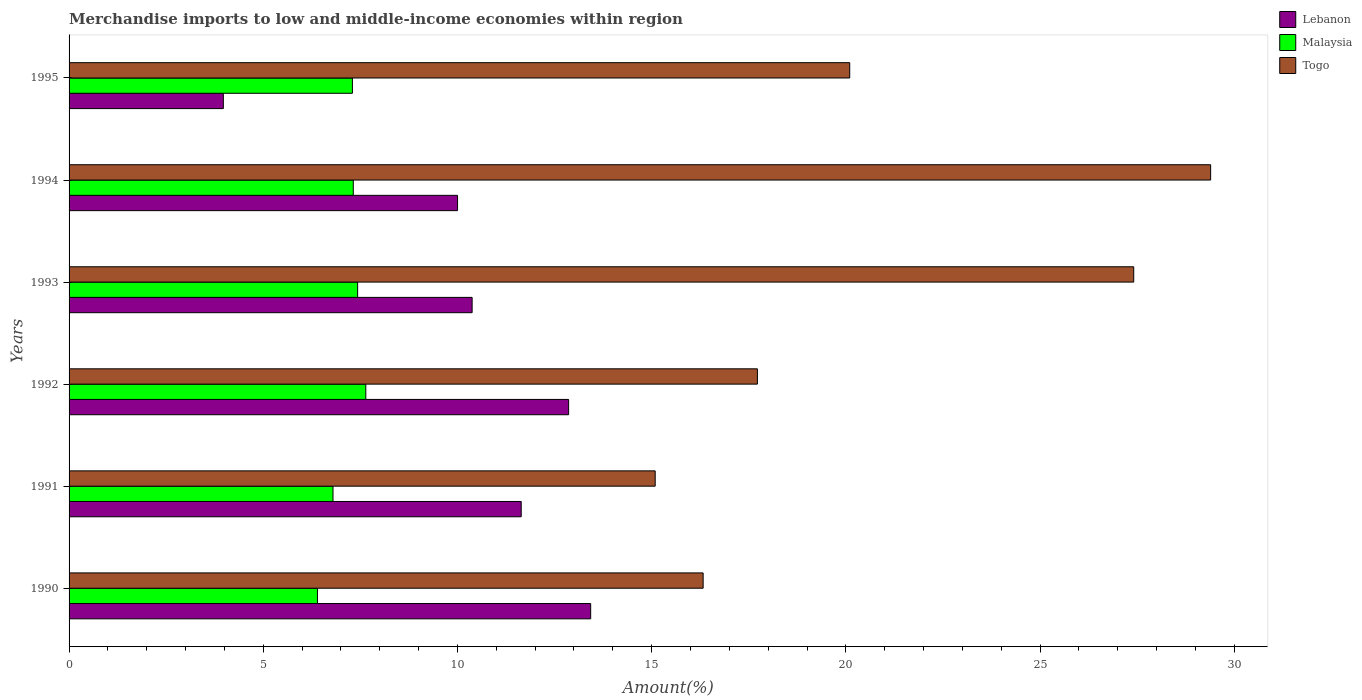How many groups of bars are there?
Provide a succinct answer. 6. How many bars are there on the 1st tick from the bottom?
Your answer should be very brief. 3. What is the percentage of amount earned from merchandise imports in Togo in 1991?
Keep it short and to the point. 15.09. Across all years, what is the maximum percentage of amount earned from merchandise imports in Togo?
Keep it short and to the point. 29.39. Across all years, what is the minimum percentage of amount earned from merchandise imports in Togo?
Your answer should be very brief. 15.09. In which year was the percentage of amount earned from merchandise imports in Lebanon maximum?
Offer a terse response. 1990. What is the total percentage of amount earned from merchandise imports in Malaysia in the graph?
Offer a very short reply. 42.87. What is the difference between the percentage of amount earned from merchandise imports in Togo in 1990 and that in 1994?
Your answer should be compact. -13.07. What is the difference between the percentage of amount earned from merchandise imports in Lebanon in 1990 and the percentage of amount earned from merchandise imports in Togo in 1995?
Provide a succinct answer. -6.67. What is the average percentage of amount earned from merchandise imports in Malaysia per year?
Ensure brevity in your answer.  7.15. In the year 1993, what is the difference between the percentage of amount earned from merchandise imports in Togo and percentage of amount earned from merchandise imports in Lebanon?
Your response must be concise. 17.03. In how many years, is the percentage of amount earned from merchandise imports in Togo greater than 1 %?
Your answer should be compact. 6. What is the ratio of the percentage of amount earned from merchandise imports in Malaysia in 1991 to that in 1993?
Make the answer very short. 0.91. Is the percentage of amount earned from merchandise imports in Togo in 1993 less than that in 1994?
Offer a very short reply. Yes. What is the difference between the highest and the second highest percentage of amount earned from merchandise imports in Togo?
Your answer should be very brief. 1.98. What is the difference between the highest and the lowest percentage of amount earned from merchandise imports in Lebanon?
Ensure brevity in your answer.  9.46. Is the sum of the percentage of amount earned from merchandise imports in Lebanon in 1991 and 1993 greater than the maximum percentage of amount earned from merchandise imports in Malaysia across all years?
Keep it short and to the point. Yes. What does the 2nd bar from the top in 1990 represents?
Keep it short and to the point. Malaysia. What does the 2nd bar from the bottom in 1993 represents?
Your response must be concise. Malaysia. What is the difference between two consecutive major ticks on the X-axis?
Keep it short and to the point. 5. Does the graph contain grids?
Your answer should be very brief. No. How are the legend labels stacked?
Offer a very short reply. Vertical. What is the title of the graph?
Keep it short and to the point. Merchandise imports to low and middle-income economies within region. What is the label or title of the X-axis?
Keep it short and to the point. Amount(%). What is the label or title of the Y-axis?
Provide a succinct answer. Years. What is the Amount(%) of Lebanon in 1990?
Your answer should be very brief. 13.43. What is the Amount(%) in Malaysia in 1990?
Keep it short and to the point. 6.4. What is the Amount(%) in Togo in 1990?
Offer a terse response. 16.33. What is the Amount(%) of Lebanon in 1991?
Make the answer very short. 11.64. What is the Amount(%) of Malaysia in 1991?
Provide a succinct answer. 6.8. What is the Amount(%) of Togo in 1991?
Provide a short and direct response. 15.09. What is the Amount(%) in Lebanon in 1992?
Your answer should be very brief. 12.86. What is the Amount(%) in Malaysia in 1992?
Ensure brevity in your answer.  7.64. What is the Amount(%) of Togo in 1992?
Offer a terse response. 17.72. What is the Amount(%) in Lebanon in 1993?
Your response must be concise. 10.38. What is the Amount(%) of Malaysia in 1993?
Your answer should be compact. 7.43. What is the Amount(%) in Togo in 1993?
Your answer should be compact. 27.41. What is the Amount(%) of Lebanon in 1994?
Offer a terse response. 10. What is the Amount(%) in Malaysia in 1994?
Ensure brevity in your answer.  7.32. What is the Amount(%) of Togo in 1994?
Keep it short and to the point. 29.39. What is the Amount(%) of Lebanon in 1995?
Ensure brevity in your answer.  3.97. What is the Amount(%) in Malaysia in 1995?
Provide a succinct answer. 7.3. What is the Amount(%) in Togo in 1995?
Keep it short and to the point. 20.1. Across all years, what is the maximum Amount(%) in Lebanon?
Keep it short and to the point. 13.43. Across all years, what is the maximum Amount(%) in Malaysia?
Make the answer very short. 7.64. Across all years, what is the maximum Amount(%) of Togo?
Keep it short and to the point. 29.39. Across all years, what is the minimum Amount(%) of Lebanon?
Provide a succinct answer. 3.97. Across all years, what is the minimum Amount(%) of Malaysia?
Give a very brief answer. 6.4. Across all years, what is the minimum Amount(%) in Togo?
Offer a terse response. 15.09. What is the total Amount(%) of Lebanon in the graph?
Make the answer very short. 62.29. What is the total Amount(%) in Malaysia in the graph?
Offer a terse response. 42.87. What is the total Amount(%) in Togo in the graph?
Your response must be concise. 126.04. What is the difference between the Amount(%) of Lebanon in 1990 and that in 1991?
Give a very brief answer. 1.79. What is the difference between the Amount(%) of Malaysia in 1990 and that in 1991?
Your answer should be compact. -0.4. What is the difference between the Amount(%) in Togo in 1990 and that in 1991?
Provide a short and direct response. 1.23. What is the difference between the Amount(%) in Lebanon in 1990 and that in 1992?
Your answer should be compact. 0.57. What is the difference between the Amount(%) in Malaysia in 1990 and that in 1992?
Ensure brevity in your answer.  -1.24. What is the difference between the Amount(%) in Togo in 1990 and that in 1992?
Your answer should be very brief. -1.4. What is the difference between the Amount(%) in Lebanon in 1990 and that in 1993?
Provide a succinct answer. 3.05. What is the difference between the Amount(%) in Malaysia in 1990 and that in 1993?
Give a very brief answer. -1.03. What is the difference between the Amount(%) of Togo in 1990 and that in 1993?
Your response must be concise. -11.09. What is the difference between the Amount(%) in Lebanon in 1990 and that in 1994?
Your answer should be very brief. 3.43. What is the difference between the Amount(%) in Malaysia in 1990 and that in 1994?
Make the answer very short. -0.92. What is the difference between the Amount(%) of Togo in 1990 and that in 1994?
Ensure brevity in your answer.  -13.07. What is the difference between the Amount(%) in Lebanon in 1990 and that in 1995?
Provide a short and direct response. 9.46. What is the difference between the Amount(%) of Malaysia in 1990 and that in 1995?
Your answer should be very brief. -0.9. What is the difference between the Amount(%) of Togo in 1990 and that in 1995?
Give a very brief answer. -3.77. What is the difference between the Amount(%) of Lebanon in 1991 and that in 1992?
Your answer should be compact. -1.22. What is the difference between the Amount(%) in Malaysia in 1991 and that in 1992?
Offer a very short reply. -0.84. What is the difference between the Amount(%) in Togo in 1991 and that in 1992?
Your answer should be compact. -2.63. What is the difference between the Amount(%) of Lebanon in 1991 and that in 1993?
Your answer should be compact. 1.26. What is the difference between the Amount(%) of Malaysia in 1991 and that in 1993?
Your answer should be compact. -0.63. What is the difference between the Amount(%) in Togo in 1991 and that in 1993?
Your response must be concise. -12.32. What is the difference between the Amount(%) of Lebanon in 1991 and that in 1994?
Keep it short and to the point. 1.64. What is the difference between the Amount(%) of Malaysia in 1991 and that in 1994?
Offer a very short reply. -0.52. What is the difference between the Amount(%) in Togo in 1991 and that in 1994?
Your answer should be compact. -14.3. What is the difference between the Amount(%) of Lebanon in 1991 and that in 1995?
Give a very brief answer. 7.67. What is the difference between the Amount(%) in Malaysia in 1991 and that in 1995?
Give a very brief answer. -0.5. What is the difference between the Amount(%) in Togo in 1991 and that in 1995?
Make the answer very short. -5.01. What is the difference between the Amount(%) of Lebanon in 1992 and that in 1993?
Offer a terse response. 2.48. What is the difference between the Amount(%) of Malaysia in 1992 and that in 1993?
Offer a very short reply. 0.21. What is the difference between the Amount(%) of Togo in 1992 and that in 1993?
Make the answer very short. -9.69. What is the difference between the Amount(%) in Lebanon in 1992 and that in 1994?
Give a very brief answer. 2.86. What is the difference between the Amount(%) of Malaysia in 1992 and that in 1994?
Ensure brevity in your answer.  0.32. What is the difference between the Amount(%) in Togo in 1992 and that in 1994?
Ensure brevity in your answer.  -11.67. What is the difference between the Amount(%) in Lebanon in 1992 and that in 1995?
Give a very brief answer. 8.89. What is the difference between the Amount(%) of Malaysia in 1992 and that in 1995?
Your answer should be very brief. 0.34. What is the difference between the Amount(%) of Togo in 1992 and that in 1995?
Your answer should be very brief. -2.38. What is the difference between the Amount(%) of Lebanon in 1993 and that in 1994?
Give a very brief answer. 0.38. What is the difference between the Amount(%) of Malaysia in 1993 and that in 1994?
Make the answer very short. 0.11. What is the difference between the Amount(%) of Togo in 1993 and that in 1994?
Your response must be concise. -1.98. What is the difference between the Amount(%) of Lebanon in 1993 and that in 1995?
Keep it short and to the point. 6.41. What is the difference between the Amount(%) in Malaysia in 1993 and that in 1995?
Provide a succinct answer. 0.13. What is the difference between the Amount(%) of Togo in 1993 and that in 1995?
Offer a terse response. 7.31. What is the difference between the Amount(%) of Lebanon in 1994 and that in 1995?
Give a very brief answer. 6.03. What is the difference between the Amount(%) in Malaysia in 1994 and that in 1995?
Your answer should be compact. 0.02. What is the difference between the Amount(%) in Togo in 1994 and that in 1995?
Make the answer very short. 9.29. What is the difference between the Amount(%) of Lebanon in 1990 and the Amount(%) of Malaysia in 1991?
Keep it short and to the point. 6.63. What is the difference between the Amount(%) in Lebanon in 1990 and the Amount(%) in Togo in 1991?
Give a very brief answer. -1.66. What is the difference between the Amount(%) of Malaysia in 1990 and the Amount(%) of Togo in 1991?
Your answer should be very brief. -8.7. What is the difference between the Amount(%) in Lebanon in 1990 and the Amount(%) in Malaysia in 1992?
Offer a terse response. 5.79. What is the difference between the Amount(%) of Lebanon in 1990 and the Amount(%) of Togo in 1992?
Your answer should be compact. -4.29. What is the difference between the Amount(%) in Malaysia in 1990 and the Amount(%) in Togo in 1992?
Offer a very short reply. -11.33. What is the difference between the Amount(%) of Lebanon in 1990 and the Amount(%) of Malaysia in 1993?
Provide a short and direct response. 6. What is the difference between the Amount(%) in Lebanon in 1990 and the Amount(%) in Togo in 1993?
Provide a short and direct response. -13.98. What is the difference between the Amount(%) of Malaysia in 1990 and the Amount(%) of Togo in 1993?
Provide a succinct answer. -21.02. What is the difference between the Amount(%) in Lebanon in 1990 and the Amount(%) in Malaysia in 1994?
Keep it short and to the point. 6.11. What is the difference between the Amount(%) in Lebanon in 1990 and the Amount(%) in Togo in 1994?
Your answer should be compact. -15.96. What is the difference between the Amount(%) of Malaysia in 1990 and the Amount(%) of Togo in 1994?
Offer a terse response. -23. What is the difference between the Amount(%) of Lebanon in 1990 and the Amount(%) of Malaysia in 1995?
Your response must be concise. 6.13. What is the difference between the Amount(%) in Lebanon in 1990 and the Amount(%) in Togo in 1995?
Your response must be concise. -6.67. What is the difference between the Amount(%) in Malaysia in 1990 and the Amount(%) in Togo in 1995?
Your answer should be compact. -13.7. What is the difference between the Amount(%) in Lebanon in 1991 and the Amount(%) in Malaysia in 1992?
Your answer should be compact. 4. What is the difference between the Amount(%) of Lebanon in 1991 and the Amount(%) of Togo in 1992?
Give a very brief answer. -6.08. What is the difference between the Amount(%) of Malaysia in 1991 and the Amount(%) of Togo in 1992?
Offer a terse response. -10.93. What is the difference between the Amount(%) of Lebanon in 1991 and the Amount(%) of Malaysia in 1993?
Ensure brevity in your answer.  4.21. What is the difference between the Amount(%) in Lebanon in 1991 and the Amount(%) in Togo in 1993?
Provide a succinct answer. -15.77. What is the difference between the Amount(%) of Malaysia in 1991 and the Amount(%) of Togo in 1993?
Your response must be concise. -20.62. What is the difference between the Amount(%) in Lebanon in 1991 and the Amount(%) in Malaysia in 1994?
Offer a terse response. 4.32. What is the difference between the Amount(%) in Lebanon in 1991 and the Amount(%) in Togo in 1994?
Your response must be concise. -17.75. What is the difference between the Amount(%) of Malaysia in 1991 and the Amount(%) of Togo in 1994?
Make the answer very short. -22.6. What is the difference between the Amount(%) of Lebanon in 1991 and the Amount(%) of Malaysia in 1995?
Provide a short and direct response. 4.35. What is the difference between the Amount(%) of Lebanon in 1991 and the Amount(%) of Togo in 1995?
Give a very brief answer. -8.46. What is the difference between the Amount(%) of Malaysia in 1991 and the Amount(%) of Togo in 1995?
Ensure brevity in your answer.  -13.3. What is the difference between the Amount(%) of Lebanon in 1992 and the Amount(%) of Malaysia in 1993?
Give a very brief answer. 5.43. What is the difference between the Amount(%) in Lebanon in 1992 and the Amount(%) in Togo in 1993?
Your answer should be compact. -14.55. What is the difference between the Amount(%) in Malaysia in 1992 and the Amount(%) in Togo in 1993?
Your response must be concise. -19.77. What is the difference between the Amount(%) in Lebanon in 1992 and the Amount(%) in Malaysia in 1994?
Your response must be concise. 5.54. What is the difference between the Amount(%) of Lebanon in 1992 and the Amount(%) of Togo in 1994?
Give a very brief answer. -16.53. What is the difference between the Amount(%) of Malaysia in 1992 and the Amount(%) of Togo in 1994?
Provide a short and direct response. -21.75. What is the difference between the Amount(%) in Lebanon in 1992 and the Amount(%) in Malaysia in 1995?
Give a very brief answer. 5.57. What is the difference between the Amount(%) of Lebanon in 1992 and the Amount(%) of Togo in 1995?
Offer a very short reply. -7.24. What is the difference between the Amount(%) in Malaysia in 1992 and the Amount(%) in Togo in 1995?
Provide a short and direct response. -12.46. What is the difference between the Amount(%) in Lebanon in 1993 and the Amount(%) in Malaysia in 1994?
Give a very brief answer. 3.06. What is the difference between the Amount(%) in Lebanon in 1993 and the Amount(%) in Togo in 1994?
Give a very brief answer. -19.02. What is the difference between the Amount(%) in Malaysia in 1993 and the Amount(%) in Togo in 1994?
Provide a short and direct response. -21.96. What is the difference between the Amount(%) of Lebanon in 1993 and the Amount(%) of Malaysia in 1995?
Offer a terse response. 3.08. What is the difference between the Amount(%) in Lebanon in 1993 and the Amount(%) in Togo in 1995?
Offer a very short reply. -9.72. What is the difference between the Amount(%) in Malaysia in 1993 and the Amount(%) in Togo in 1995?
Your response must be concise. -12.67. What is the difference between the Amount(%) in Lebanon in 1994 and the Amount(%) in Malaysia in 1995?
Make the answer very short. 2.71. What is the difference between the Amount(%) in Lebanon in 1994 and the Amount(%) in Togo in 1995?
Make the answer very short. -10.1. What is the difference between the Amount(%) of Malaysia in 1994 and the Amount(%) of Togo in 1995?
Give a very brief answer. -12.78. What is the average Amount(%) of Lebanon per year?
Offer a very short reply. 10.38. What is the average Amount(%) of Malaysia per year?
Your answer should be compact. 7.15. What is the average Amount(%) in Togo per year?
Your answer should be compact. 21.01. In the year 1990, what is the difference between the Amount(%) in Lebanon and Amount(%) in Malaysia?
Make the answer very short. 7.03. In the year 1990, what is the difference between the Amount(%) in Lebanon and Amount(%) in Togo?
Your answer should be very brief. -2.9. In the year 1990, what is the difference between the Amount(%) in Malaysia and Amount(%) in Togo?
Your answer should be very brief. -9.93. In the year 1991, what is the difference between the Amount(%) of Lebanon and Amount(%) of Malaysia?
Your answer should be compact. 4.85. In the year 1991, what is the difference between the Amount(%) of Lebanon and Amount(%) of Togo?
Offer a very short reply. -3.45. In the year 1991, what is the difference between the Amount(%) of Malaysia and Amount(%) of Togo?
Keep it short and to the point. -8.3. In the year 1992, what is the difference between the Amount(%) in Lebanon and Amount(%) in Malaysia?
Keep it short and to the point. 5.22. In the year 1992, what is the difference between the Amount(%) in Lebanon and Amount(%) in Togo?
Offer a very short reply. -4.86. In the year 1992, what is the difference between the Amount(%) in Malaysia and Amount(%) in Togo?
Your response must be concise. -10.08. In the year 1993, what is the difference between the Amount(%) in Lebanon and Amount(%) in Malaysia?
Provide a succinct answer. 2.95. In the year 1993, what is the difference between the Amount(%) in Lebanon and Amount(%) in Togo?
Provide a short and direct response. -17.03. In the year 1993, what is the difference between the Amount(%) of Malaysia and Amount(%) of Togo?
Offer a terse response. -19.98. In the year 1994, what is the difference between the Amount(%) in Lebanon and Amount(%) in Malaysia?
Provide a succinct answer. 2.68. In the year 1994, what is the difference between the Amount(%) of Lebanon and Amount(%) of Togo?
Give a very brief answer. -19.39. In the year 1994, what is the difference between the Amount(%) in Malaysia and Amount(%) in Togo?
Offer a very short reply. -22.07. In the year 1995, what is the difference between the Amount(%) in Lebanon and Amount(%) in Malaysia?
Make the answer very short. -3.32. In the year 1995, what is the difference between the Amount(%) of Lebanon and Amount(%) of Togo?
Your answer should be compact. -16.13. In the year 1995, what is the difference between the Amount(%) of Malaysia and Amount(%) of Togo?
Give a very brief answer. -12.8. What is the ratio of the Amount(%) of Lebanon in 1990 to that in 1991?
Offer a very short reply. 1.15. What is the ratio of the Amount(%) of Malaysia in 1990 to that in 1991?
Offer a terse response. 0.94. What is the ratio of the Amount(%) of Togo in 1990 to that in 1991?
Ensure brevity in your answer.  1.08. What is the ratio of the Amount(%) in Lebanon in 1990 to that in 1992?
Ensure brevity in your answer.  1.04. What is the ratio of the Amount(%) in Malaysia in 1990 to that in 1992?
Your answer should be very brief. 0.84. What is the ratio of the Amount(%) in Togo in 1990 to that in 1992?
Your answer should be compact. 0.92. What is the ratio of the Amount(%) in Lebanon in 1990 to that in 1993?
Keep it short and to the point. 1.29. What is the ratio of the Amount(%) in Malaysia in 1990 to that in 1993?
Make the answer very short. 0.86. What is the ratio of the Amount(%) of Togo in 1990 to that in 1993?
Provide a short and direct response. 0.6. What is the ratio of the Amount(%) in Lebanon in 1990 to that in 1994?
Your answer should be very brief. 1.34. What is the ratio of the Amount(%) in Malaysia in 1990 to that in 1994?
Offer a terse response. 0.87. What is the ratio of the Amount(%) in Togo in 1990 to that in 1994?
Your answer should be very brief. 0.56. What is the ratio of the Amount(%) of Lebanon in 1990 to that in 1995?
Your answer should be compact. 3.38. What is the ratio of the Amount(%) in Malaysia in 1990 to that in 1995?
Your answer should be compact. 0.88. What is the ratio of the Amount(%) in Togo in 1990 to that in 1995?
Offer a very short reply. 0.81. What is the ratio of the Amount(%) in Lebanon in 1991 to that in 1992?
Provide a succinct answer. 0.91. What is the ratio of the Amount(%) in Malaysia in 1991 to that in 1992?
Give a very brief answer. 0.89. What is the ratio of the Amount(%) in Togo in 1991 to that in 1992?
Offer a terse response. 0.85. What is the ratio of the Amount(%) of Lebanon in 1991 to that in 1993?
Offer a very short reply. 1.12. What is the ratio of the Amount(%) in Malaysia in 1991 to that in 1993?
Keep it short and to the point. 0.91. What is the ratio of the Amount(%) of Togo in 1991 to that in 1993?
Keep it short and to the point. 0.55. What is the ratio of the Amount(%) in Lebanon in 1991 to that in 1994?
Provide a succinct answer. 1.16. What is the ratio of the Amount(%) of Malaysia in 1991 to that in 1994?
Give a very brief answer. 0.93. What is the ratio of the Amount(%) in Togo in 1991 to that in 1994?
Offer a terse response. 0.51. What is the ratio of the Amount(%) of Lebanon in 1991 to that in 1995?
Keep it short and to the point. 2.93. What is the ratio of the Amount(%) of Malaysia in 1991 to that in 1995?
Provide a short and direct response. 0.93. What is the ratio of the Amount(%) of Togo in 1991 to that in 1995?
Your response must be concise. 0.75. What is the ratio of the Amount(%) in Lebanon in 1992 to that in 1993?
Offer a very short reply. 1.24. What is the ratio of the Amount(%) in Malaysia in 1992 to that in 1993?
Your response must be concise. 1.03. What is the ratio of the Amount(%) of Togo in 1992 to that in 1993?
Offer a terse response. 0.65. What is the ratio of the Amount(%) in Lebanon in 1992 to that in 1994?
Keep it short and to the point. 1.29. What is the ratio of the Amount(%) in Malaysia in 1992 to that in 1994?
Ensure brevity in your answer.  1.04. What is the ratio of the Amount(%) in Togo in 1992 to that in 1994?
Your answer should be compact. 0.6. What is the ratio of the Amount(%) in Lebanon in 1992 to that in 1995?
Your answer should be very brief. 3.24. What is the ratio of the Amount(%) in Malaysia in 1992 to that in 1995?
Provide a short and direct response. 1.05. What is the ratio of the Amount(%) in Togo in 1992 to that in 1995?
Your answer should be compact. 0.88. What is the ratio of the Amount(%) of Lebanon in 1993 to that in 1994?
Ensure brevity in your answer.  1.04. What is the ratio of the Amount(%) in Malaysia in 1993 to that in 1994?
Your response must be concise. 1.02. What is the ratio of the Amount(%) of Togo in 1993 to that in 1994?
Give a very brief answer. 0.93. What is the ratio of the Amount(%) in Lebanon in 1993 to that in 1995?
Make the answer very short. 2.61. What is the ratio of the Amount(%) of Malaysia in 1993 to that in 1995?
Make the answer very short. 1.02. What is the ratio of the Amount(%) in Togo in 1993 to that in 1995?
Your answer should be compact. 1.36. What is the ratio of the Amount(%) of Lebanon in 1994 to that in 1995?
Keep it short and to the point. 2.52. What is the ratio of the Amount(%) in Malaysia in 1994 to that in 1995?
Your response must be concise. 1. What is the ratio of the Amount(%) of Togo in 1994 to that in 1995?
Provide a succinct answer. 1.46. What is the difference between the highest and the second highest Amount(%) of Lebanon?
Ensure brevity in your answer.  0.57. What is the difference between the highest and the second highest Amount(%) in Malaysia?
Keep it short and to the point. 0.21. What is the difference between the highest and the second highest Amount(%) of Togo?
Keep it short and to the point. 1.98. What is the difference between the highest and the lowest Amount(%) of Lebanon?
Give a very brief answer. 9.46. What is the difference between the highest and the lowest Amount(%) in Malaysia?
Your response must be concise. 1.24. What is the difference between the highest and the lowest Amount(%) of Togo?
Your response must be concise. 14.3. 